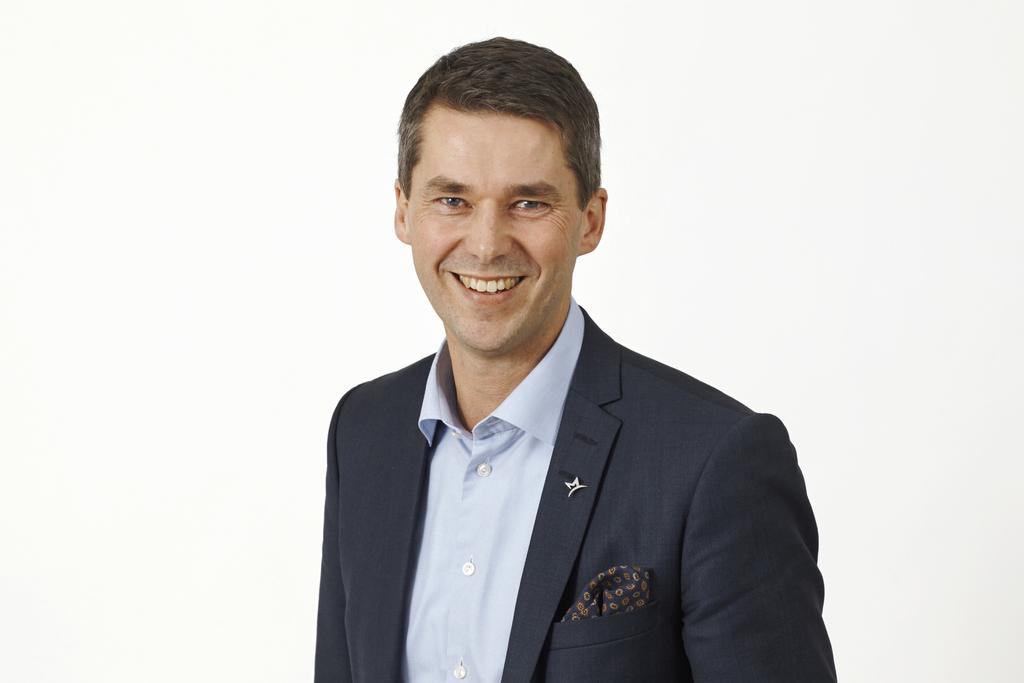What is the main subject of the image? There is a person in the image. What color is the background of the image? The background of the image is white in color. What type of yarn is the person holding in the image? There is no yarn present in the image. Is there a servant attending to the person in the image? There is no mention of a servant or any other person in the image. 